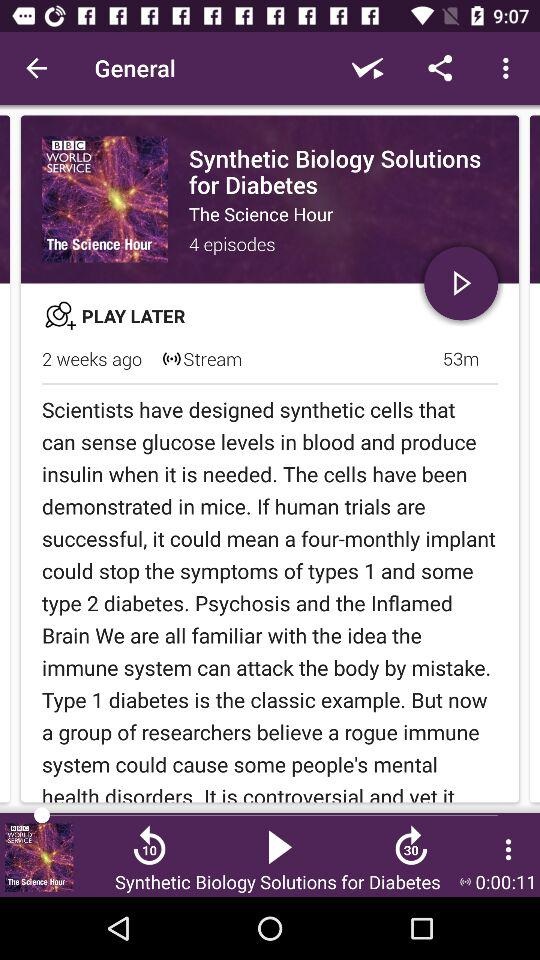What can synthetic cells do? Synthetic cells can sense glucose levels in blood and produce insulin when it is needed. 